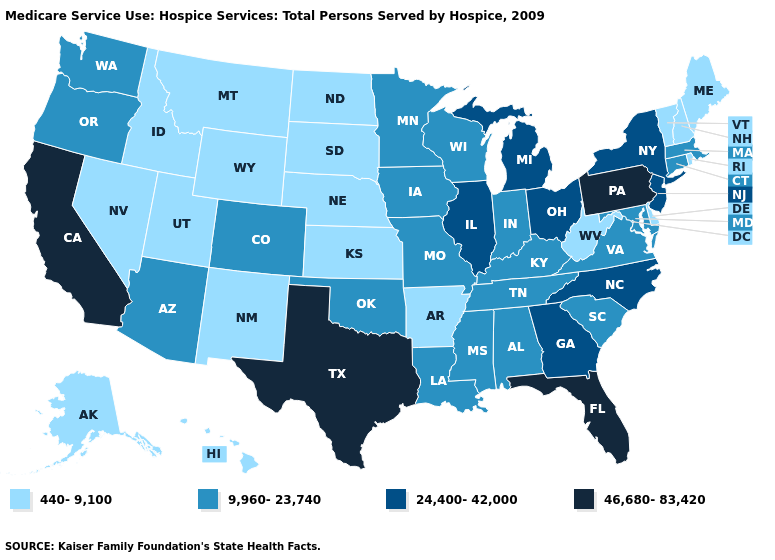Does Montana have the highest value in the USA?
Write a very short answer. No. What is the value of Mississippi?
Answer briefly. 9,960-23,740. Does New Mexico have the lowest value in the USA?
Answer briefly. Yes. Does California have the highest value in the USA?
Answer briefly. Yes. Does the first symbol in the legend represent the smallest category?
Concise answer only. Yes. What is the value of Iowa?
Short answer required. 9,960-23,740. What is the lowest value in the USA?
Write a very short answer. 440-9,100. Does Louisiana have a lower value than Alabama?
Concise answer only. No. What is the highest value in the USA?
Answer briefly. 46,680-83,420. Name the states that have a value in the range 24,400-42,000?
Give a very brief answer. Georgia, Illinois, Michigan, New Jersey, New York, North Carolina, Ohio. Among the states that border North Dakota , does Montana have the lowest value?
Give a very brief answer. Yes. Which states have the lowest value in the USA?
Answer briefly. Alaska, Arkansas, Delaware, Hawaii, Idaho, Kansas, Maine, Montana, Nebraska, Nevada, New Hampshire, New Mexico, North Dakota, Rhode Island, South Dakota, Utah, Vermont, West Virginia, Wyoming. What is the lowest value in the West?
Give a very brief answer. 440-9,100. Name the states that have a value in the range 24,400-42,000?
Short answer required. Georgia, Illinois, Michigan, New Jersey, New York, North Carolina, Ohio. What is the value of Kentucky?
Give a very brief answer. 9,960-23,740. 